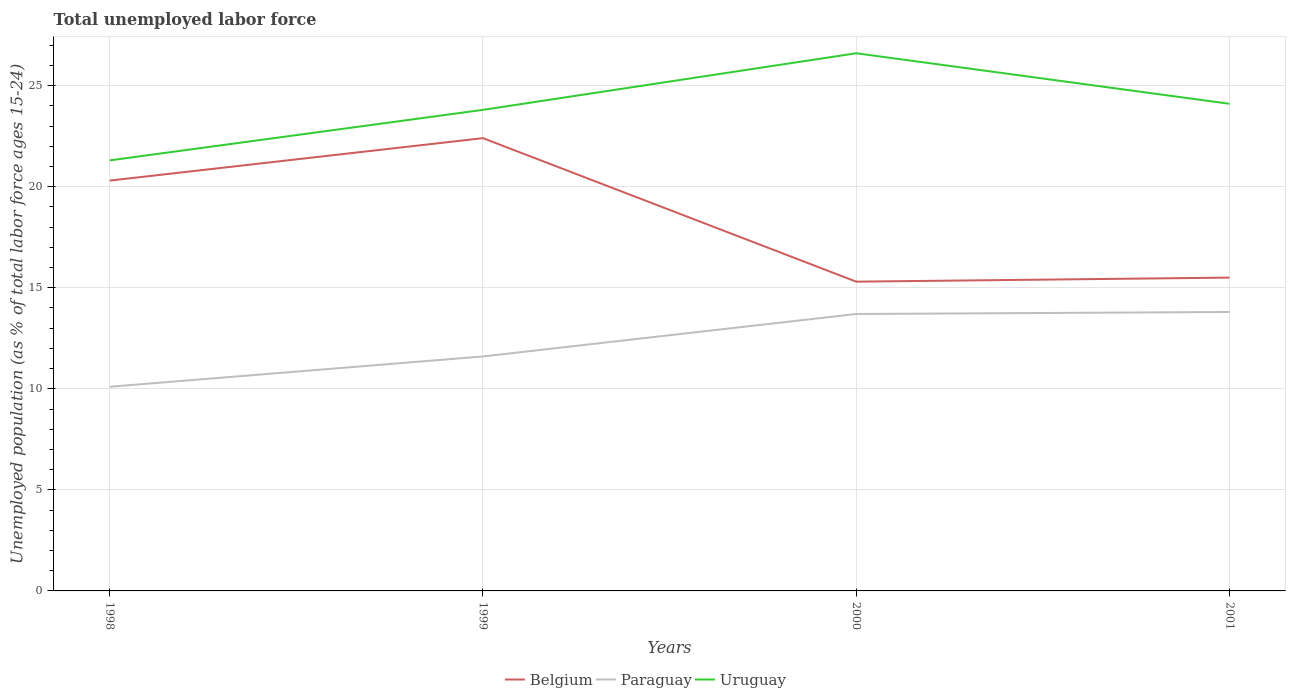How many different coloured lines are there?
Make the answer very short. 3. Is the number of lines equal to the number of legend labels?
Provide a short and direct response. Yes. Across all years, what is the maximum percentage of unemployed population in in Uruguay?
Keep it short and to the point. 21.3. In which year was the percentage of unemployed population in in Belgium maximum?
Your response must be concise. 2000. What is the total percentage of unemployed population in in Belgium in the graph?
Give a very brief answer. 5. What is the difference between the highest and the second highest percentage of unemployed population in in Paraguay?
Make the answer very short. 3.7. Is the percentage of unemployed population in in Uruguay strictly greater than the percentage of unemployed population in in Paraguay over the years?
Your answer should be very brief. No. How many lines are there?
Your answer should be compact. 3. How many years are there in the graph?
Provide a succinct answer. 4. Are the values on the major ticks of Y-axis written in scientific E-notation?
Provide a succinct answer. No. Does the graph contain any zero values?
Ensure brevity in your answer.  No. Does the graph contain grids?
Make the answer very short. Yes. How many legend labels are there?
Your answer should be compact. 3. How are the legend labels stacked?
Your answer should be compact. Horizontal. What is the title of the graph?
Give a very brief answer. Total unemployed labor force. Does "Turkey" appear as one of the legend labels in the graph?
Your answer should be compact. No. What is the label or title of the Y-axis?
Provide a short and direct response. Unemployed population (as % of total labor force ages 15-24). What is the Unemployed population (as % of total labor force ages 15-24) of Belgium in 1998?
Offer a very short reply. 20.3. What is the Unemployed population (as % of total labor force ages 15-24) of Paraguay in 1998?
Keep it short and to the point. 10.1. What is the Unemployed population (as % of total labor force ages 15-24) of Uruguay in 1998?
Your response must be concise. 21.3. What is the Unemployed population (as % of total labor force ages 15-24) of Belgium in 1999?
Keep it short and to the point. 22.4. What is the Unemployed population (as % of total labor force ages 15-24) in Paraguay in 1999?
Provide a succinct answer. 11.6. What is the Unemployed population (as % of total labor force ages 15-24) of Uruguay in 1999?
Make the answer very short. 23.8. What is the Unemployed population (as % of total labor force ages 15-24) in Belgium in 2000?
Your response must be concise. 15.3. What is the Unemployed population (as % of total labor force ages 15-24) in Paraguay in 2000?
Your answer should be very brief. 13.7. What is the Unemployed population (as % of total labor force ages 15-24) in Uruguay in 2000?
Provide a short and direct response. 26.6. What is the Unemployed population (as % of total labor force ages 15-24) in Paraguay in 2001?
Offer a very short reply. 13.8. What is the Unemployed population (as % of total labor force ages 15-24) in Uruguay in 2001?
Your answer should be compact. 24.1. Across all years, what is the maximum Unemployed population (as % of total labor force ages 15-24) of Belgium?
Ensure brevity in your answer.  22.4. Across all years, what is the maximum Unemployed population (as % of total labor force ages 15-24) in Paraguay?
Your answer should be compact. 13.8. Across all years, what is the maximum Unemployed population (as % of total labor force ages 15-24) of Uruguay?
Offer a terse response. 26.6. Across all years, what is the minimum Unemployed population (as % of total labor force ages 15-24) of Belgium?
Offer a terse response. 15.3. Across all years, what is the minimum Unemployed population (as % of total labor force ages 15-24) of Paraguay?
Offer a terse response. 10.1. Across all years, what is the minimum Unemployed population (as % of total labor force ages 15-24) of Uruguay?
Offer a very short reply. 21.3. What is the total Unemployed population (as % of total labor force ages 15-24) of Belgium in the graph?
Ensure brevity in your answer.  73.5. What is the total Unemployed population (as % of total labor force ages 15-24) of Paraguay in the graph?
Make the answer very short. 49.2. What is the total Unemployed population (as % of total labor force ages 15-24) in Uruguay in the graph?
Make the answer very short. 95.8. What is the difference between the Unemployed population (as % of total labor force ages 15-24) of Belgium in 1998 and that in 1999?
Your answer should be very brief. -2.1. What is the difference between the Unemployed population (as % of total labor force ages 15-24) of Uruguay in 1998 and that in 2000?
Keep it short and to the point. -5.3. What is the difference between the Unemployed population (as % of total labor force ages 15-24) in Paraguay in 1998 and that in 2001?
Offer a terse response. -3.7. What is the difference between the Unemployed population (as % of total labor force ages 15-24) in Belgium in 1999 and that in 2000?
Offer a terse response. 7.1. What is the difference between the Unemployed population (as % of total labor force ages 15-24) of Uruguay in 1999 and that in 2000?
Offer a very short reply. -2.8. What is the difference between the Unemployed population (as % of total labor force ages 15-24) of Belgium in 1999 and that in 2001?
Offer a terse response. 6.9. What is the difference between the Unemployed population (as % of total labor force ages 15-24) of Paraguay in 1999 and that in 2001?
Ensure brevity in your answer.  -2.2. What is the difference between the Unemployed population (as % of total labor force ages 15-24) in Belgium in 2000 and that in 2001?
Your response must be concise. -0.2. What is the difference between the Unemployed population (as % of total labor force ages 15-24) of Paraguay in 2000 and that in 2001?
Your response must be concise. -0.1. What is the difference between the Unemployed population (as % of total labor force ages 15-24) in Uruguay in 2000 and that in 2001?
Give a very brief answer. 2.5. What is the difference between the Unemployed population (as % of total labor force ages 15-24) in Belgium in 1998 and the Unemployed population (as % of total labor force ages 15-24) in Paraguay in 1999?
Your answer should be compact. 8.7. What is the difference between the Unemployed population (as % of total labor force ages 15-24) of Paraguay in 1998 and the Unemployed population (as % of total labor force ages 15-24) of Uruguay in 1999?
Offer a terse response. -13.7. What is the difference between the Unemployed population (as % of total labor force ages 15-24) in Belgium in 1998 and the Unemployed population (as % of total labor force ages 15-24) in Paraguay in 2000?
Provide a short and direct response. 6.6. What is the difference between the Unemployed population (as % of total labor force ages 15-24) of Belgium in 1998 and the Unemployed population (as % of total labor force ages 15-24) of Uruguay in 2000?
Offer a very short reply. -6.3. What is the difference between the Unemployed population (as % of total labor force ages 15-24) of Paraguay in 1998 and the Unemployed population (as % of total labor force ages 15-24) of Uruguay in 2000?
Offer a terse response. -16.5. What is the difference between the Unemployed population (as % of total labor force ages 15-24) in Belgium in 1998 and the Unemployed population (as % of total labor force ages 15-24) in Paraguay in 2001?
Ensure brevity in your answer.  6.5. What is the difference between the Unemployed population (as % of total labor force ages 15-24) in Belgium in 1999 and the Unemployed population (as % of total labor force ages 15-24) in Uruguay in 2000?
Give a very brief answer. -4.2. What is the difference between the Unemployed population (as % of total labor force ages 15-24) in Paraguay in 1999 and the Unemployed population (as % of total labor force ages 15-24) in Uruguay in 2001?
Offer a terse response. -12.5. What is the average Unemployed population (as % of total labor force ages 15-24) in Belgium per year?
Keep it short and to the point. 18.38. What is the average Unemployed population (as % of total labor force ages 15-24) in Paraguay per year?
Your response must be concise. 12.3. What is the average Unemployed population (as % of total labor force ages 15-24) of Uruguay per year?
Your answer should be very brief. 23.95. In the year 1998, what is the difference between the Unemployed population (as % of total labor force ages 15-24) of Belgium and Unemployed population (as % of total labor force ages 15-24) of Paraguay?
Offer a very short reply. 10.2. In the year 1999, what is the difference between the Unemployed population (as % of total labor force ages 15-24) of Belgium and Unemployed population (as % of total labor force ages 15-24) of Paraguay?
Offer a very short reply. 10.8. In the year 2000, what is the difference between the Unemployed population (as % of total labor force ages 15-24) in Belgium and Unemployed population (as % of total labor force ages 15-24) in Uruguay?
Ensure brevity in your answer.  -11.3. In the year 2001, what is the difference between the Unemployed population (as % of total labor force ages 15-24) of Belgium and Unemployed population (as % of total labor force ages 15-24) of Paraguay?
Your answer should be very brief. 1.7. What is the ratio of the Unemployed population (as % of total labor force ages 15-24) of Belgium in 1998 to that in 1999?
Your answer should be compact. 0.91. What is the ratio of the Unemployed population (as % of total labor force ages 15-24) of Paraguay in 1998 to that in 1999?
Provide a succinct answer. 0.87. What is the ratio of the Unemployed population (as % of total labor force ages 15-24) in Uruguay in 1998 to that in 1999?
Your answer should be very brief. 0.9. What is the ratio of the Unemployed population (as % of total labor force ages 15-24) of Belgium in 1998 to that in 2000?
Make the answer very short. 1.33. What is the ratio of the Unemployed population (as % of total labor force ages 15-24) of Paraguay in 1998 to that in 2000?
Make the answer very short. 0.74. What is the ratio of the Unemployed population (as % of total labor force ages 15-24) in Uruguay in 1998 to that in 2000?
Offer a very short reply. 0.8. What is the ratio of the Unemployed population (as % of total labor force ages 15-24) in Belgium in 1998 to that in 2001?
Give a very brief answer. 1.31. What is the ratio of the Unemployed population (as % of total labor force ages 15-24) in Paraguay in 1998 to that in 2001?
Keep it short and to the point. 0.73. What is the ratio of the Unemployed population (as % of total labor force ages 15-24) of Uruguay in 1998 to that in 2001?
Your response must be concise. 0.88. What is the ratio of the Unemployed population (as % of total labor force ages 15-24) in Belgium in 1999 to that in 2000?
Provide a succinct answer. 1.46. What is the ratio of the Unemployed population (as % of total labor force ages 15-24) in Paraguay in 1999 to that in 2000?
Your response must be concise. 0.85. What is the ratio of the Unemployed population (as % of total labor force ages 15-24) of Uruguay in 1999 to that in 2000?
Your answer should be very brief. 0.89. What is the ratio of the Unemployed population (as % of total labor force ages 15-24) in Belgium in 1999 to that in 2001?
Offer a terse response. 1.45. What is the ratio of the Unemployed population (as % of total labor force ages 15-24) of Paraguay in 1999 to that in 2001?
Offer a terse response. 0.84. What is the ratio of the Unemployed population (as % of total labor force ages 15-24) of Uruguay in 1999 to that in 2001?
Provide a short and direct response. 0.99. What is the ratio of the Unemployed population (as % of total labor force ages 15-24) in Belgium in 2000 to that in 2001?
Your answer should be very brief. 0.99. What is the ratio of the Unemployed population (as % of total labor force ages 15-24) in Paraguay in 2000 to that in 2001?
Provide a succinct answer. 0.99. What is the ratio of the Unemployed population (as % of total labor force ages 15-24) in Uruguay in 2000 to that in 2001?
Your answer should be compact. 1.1. What is the difference between the highest and the lowest Unemployed population (as % of total labor force ages 15-24) of Belgium?
Provide a short and direct response. 7.1. What is the difference between the highest and the lowest Unemployed population (as % of total labor force ages 15-24) in Uruguay?
Make the answer very short. 5.3. 